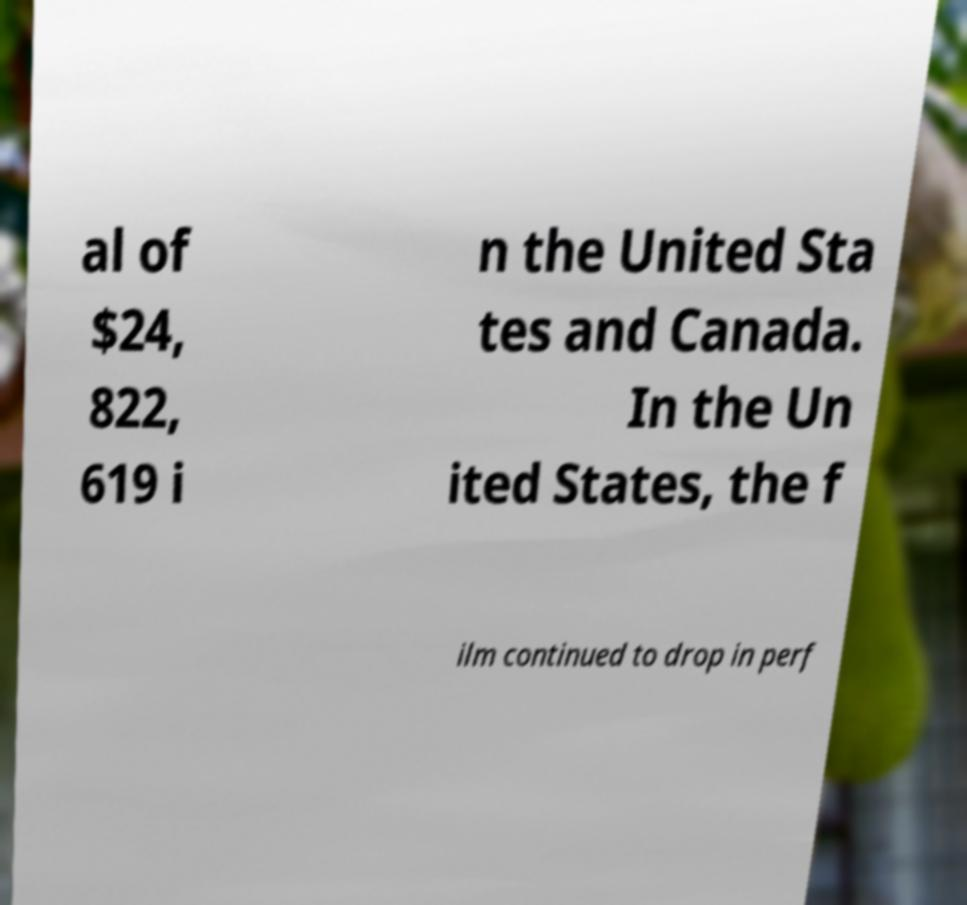Can you accurately transcribe the text from the provided image for me? al of $24, 822, 619 i n the United Sta tes and Canada. In the Un ited States, the f ilm continued to drop in perf 